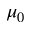Convert formula to latex. <formula><loc_0><loc_0><loc_500><loc_500>\mu _ { 0 }</formula> 